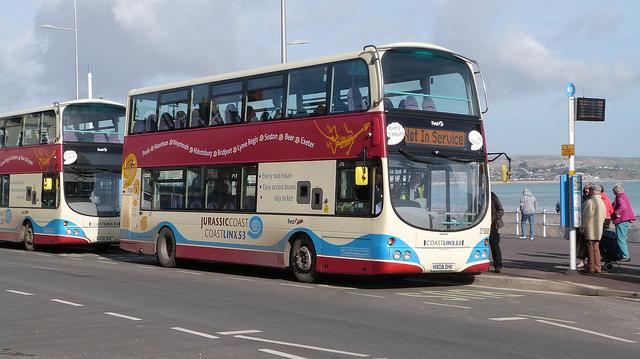What is the main color of the bus?
Write a very short answer. White. Is the bus in a city?
Quick response, please. Yes. Is the front bus in service?
Write a very short answer. No. How many decks does the bus have?
Concise answer only. 2. Is this a double decker bus?
Answer briefly. Yes. How many buses in the picture?
Give a very brief answer. 2. 